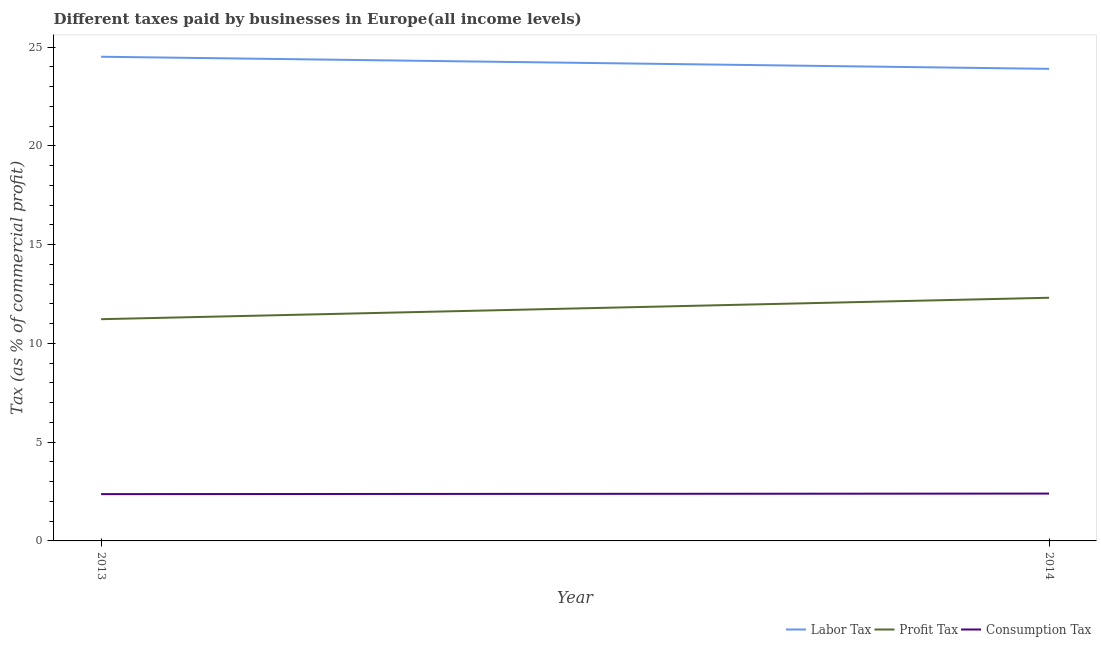Does the line corresponding to percentage of labor tax intersect with the line corresponding to percentage of consumption tax?
Your response must be concise. No. What is the percentage of consumption tax in 2014?
Give a very brief answer. 2.4. Across all years, what is the maximum percentage of labor tax?
Keep it short and to the point. 24.51. Across all years, what is the minimum percentage of labor tax?
Offer a very short reply. 23.9. What is the total percentage of consumption tax in the graph?
Make the answer very short. 4.76. What is the difference between the percentage of labor tax in 2013 and that in 2014?
Your answer should be very brief. 0.61. What is the difference between the percentage of labor tax in 2013 and the percentage of consumption tax in 2014?
Keep it short and to the point. 22.11. What is the average percentage of labor tax per year?
Your answer should be compact. 24.2. In the year 2014, what is the difference between the percentage of consumption tax and percentage of profit tax?
Your answer should be very brief. -9.91. What is the ratio of the percentage of profit tax in 2013 to that in 2014?
Offer a terse response. 0.91. Is the percentage of consumption tax in 2013 less than that in 2014?
Ensure brevity in your answer.  Yes. Is the percentage of profit tax strictly greater than the percentage of consumption tax over the years?
Offer a terse response. Yes. How many years are there in the graph?
Offer a terse response. 2. Does the graph contain any zero values?
Offer a terse response. No. How many legend labels are there?
Give a very brief answer. 3. How are the legend labels stacked?
Make the answer very short. Horizontal. What is the title of the graph?
Offer a very short reply. Different taxes paid by businesses in Europe(all income levels). What is the label or title of the Y-axis?
Provide a short and direct response. Tax (as % of commercial profit). What is the Tax (as % of commercial profit) in Labor Tax in 2013?
Your answer should be very brief. 24.51. What is the Tax (as % of commercial profit) of Profit Tax in 2013?
Keep it short and to the point. 11.22. What is the Tax (as % of commercial profit) in Consumption Tax in 2013?
Make the answer very short. 2.37. What is the Tax (as % of commercial profit) of Labor Tax in 2014?
Your response must be concise. 23.9. What is the Tax (as % of commercial profit) of Profit Tax in 2014?
Give a very brief answer. 12.31. What is the Tax (as % of commercial profit) in Consumption Tax in 2014?
Provide a short and direct response. 2.4. Across all years, what is the maximum Tax (as % of commercial profit) of Labor Tax?
Your response must be concise. 24.51. Across all years, what is the maximum Tax (as % of commercial profit) in Profit Tax?
Offer a very short reply. 12.31. Across all years, what is the maximum Tax (as % of commercial profit) in Consumption Tax?
Keep it short and to the point. 2.4. Across all years, what is the minimum Tax (as % of commercial profit) of Labor Tax?
Give a very brief answer. 23.9. Across all years, what is the minimum Tax (as % of commercial profit) of Profit Tax?
Give a very brief answer. 11.22. Across all years, what is the minimum Tax (as % of commercial profit) of Consumption Tax?
Offer a terse response. 2.37. What is the total Tax (as % of commercial profit) in Labor Tax in the graph?
Keep it short and to the point. 48.4. What is the total Tax (as % of commercial profit) of Profit Tax in the graph?
Ensure brevity in your answer.  23.53. What is the total Tax (as % of commercial profit) in Consumption Tax in the graph?
Provide a short and direct response. 4.76. What is the difference between the Tax (as % of commercial profit) in Labor Tax in 2013 and that in 2014?
Your answer should be compact. 0.61. What is the difference between the Tax (as % of commercial profit) in Profit Tax in 2013 and that in 2014?
Your response must be concise. -1.08. What is the difference between the Tax (as % of commercial profit) of Consumption Tax in 2013 and that in 2014?
Give a very brief answer. -0.03. What is the difference between the Tax (as % of commercial profit) in Labor Tax in 2013 and the Tax (as % of commercial profit) in Profit Tax in 2014?
Keep it short and to the point. 12.2. What is the difference between the Tax (as % of commercial profit) of Labor Tax in 2013 and the Tax (as % of commercial profit) of Consumption Tax in 2014?
Provide a short and direct response. 22.11. What is the difference between the Tax (as % of commercial profit) in Profit Tax in 2013 and the Tax (as % of commercial profit) in Consumption Tax in 2014?
Your answer should be very brief. 8.83. What is the average Tax (as % of commercial profit) of Labor Tax per year?
Provide a short and direct response. 24.2. What is the average Tax (as % of commercial profit) of Profit Tax per year?
Give a very brief answer. 11.77. What is the average Tax (as % of commercial profit) of Consumption Tax per year?
Ensure brevity in your answer.  2.38. In the year 2013, what is the difference between the Tax (as % of commercial profit) of Labor Tax and Tax (as % of commercial profit) of Profit Tax?
Your response must be concise. 13.29. In the year 2013, what is the difference between the Tax (as % of commercial profit) in Labor Tax and Tax (as % of commercial profit) in Consumption Tax?
Offer a terse response. 22.14. In the year 2013, what is the difference between the Tax (as % of commercial profit) of Profit Tax and Tax (as % of commercial profit) of Consumption Tax?
Offer a terse response. 8.85. In the year 2014, what is the difference between the Tax (as % of commercial profit) of Labor Tax and Tax (as % of commercial profit) of Profit Tax?
Make the answer very short. 11.59. In the year 2014, what is the difference between the Tax (as % of commercial profit) of Profit Tax and Tax (as % of commercial profit) of Consumption Tax?
Your answer should be compact. 9.91. What is the ratio of the Tax (as % of commercial profit) of Labor Tax in 2013 to that in 2014?
Make the answer very short. 1.03. What is the ratio of the Tax (as % of commercial profit) of Profit Tax in 2013 to that in 2014?
Ensure brevity in your answer.  0.91. What is the ratio of the Tax (as % of commercial profit) of Consumption Tax in 2013 to that in 2014?
Provide a succinct answer. 0.99. What is the difference between the highest and the second highest Tax (as % of commercial profit) of Labor Tax?
Provide a succinct answer. 0.61. What is the difference between the highest and the second highest Tax (as % of commercial profit) in Profit Tax?
Ensure brevity in your answer.  1.08. What is the difference between the highest and the second highest Tax (as % of commercial profit) in Consumption Tax?
Offer a terse response. 0.03. What is the difference between the highest and the lowest Tax (as % of commercial profit) in Labor Tax?
Provide a short and direct response. 0.61. What is the difference between the highest and the lowest Tax (as % of commercial profit) in Profit Tax?
Ensure brevity in your answer.  1.08. What is the difference between the highest and the lowest Tax (as % of commercial profit) in Consumption Tax?
Ensure brevity in your answer.  0.03. 